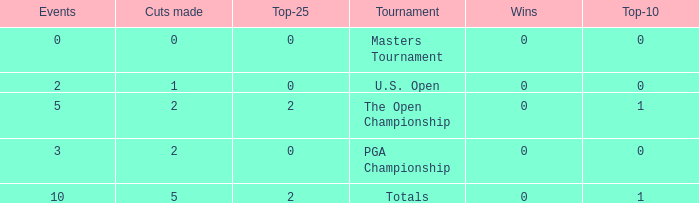What is the sum of top-10s for events with more than 0 wins? None. 